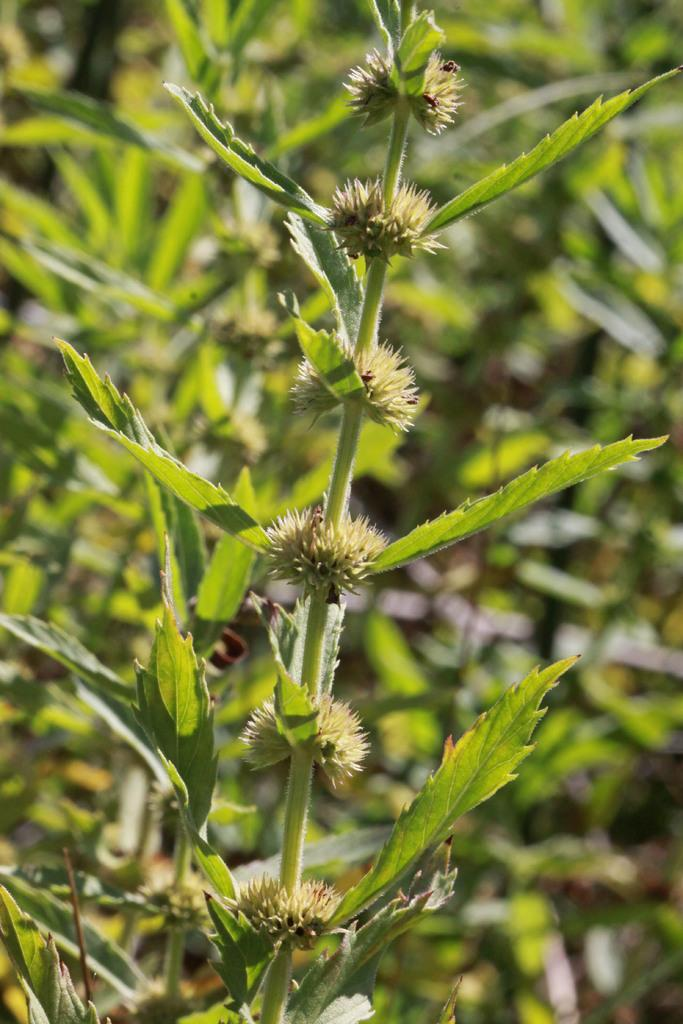What is located in the foreground of the picture? There is a plant in the foreground of the picture. How would you describe the background of the image? The background of the image is blurred. What type of environment can be seen in the background of the image? There is greenery visible in the background of the image. What type of polish is being applied to the sock in the image? There is no polish or sock present in the image; it features a plant in the foreground and greenery in the background. 